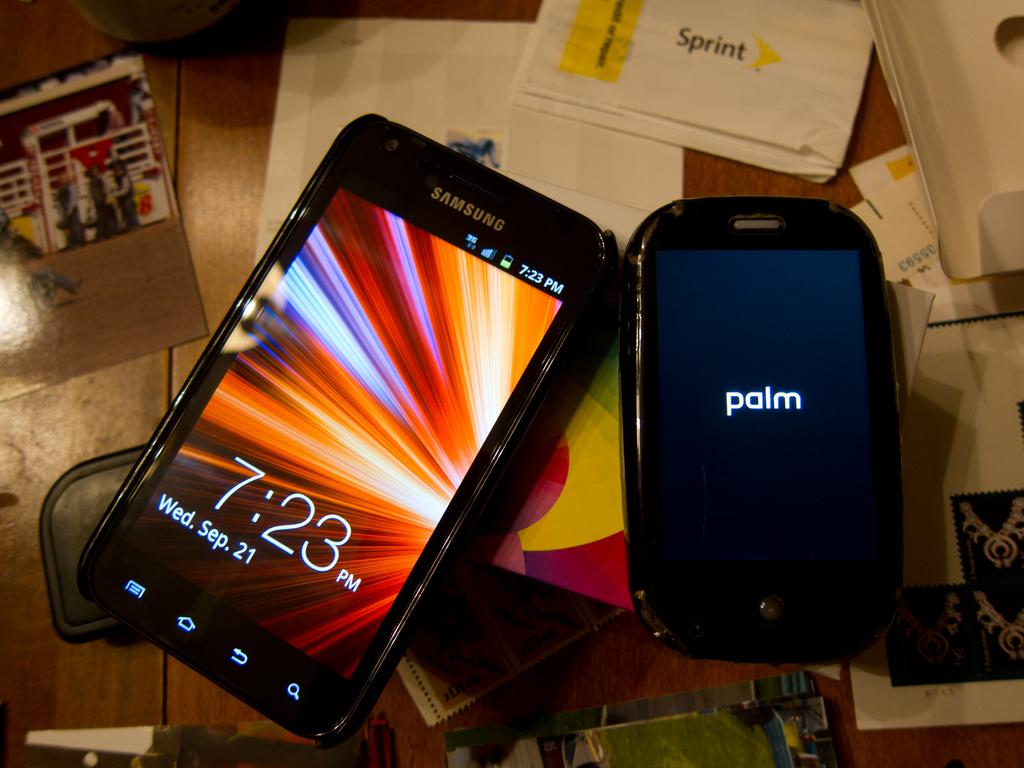<image>
Give a short and clear explanation of the subsequent image. A palm device on a wooden table at 7:23 PM on September 21. 